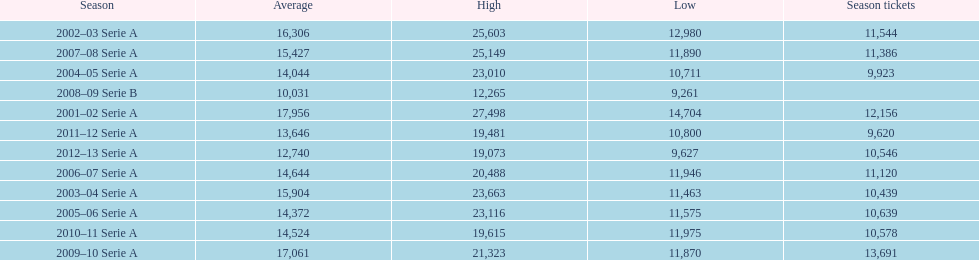How many seasons had average attendance of at least 15,000 at the stadio ennio tardini? 5. 